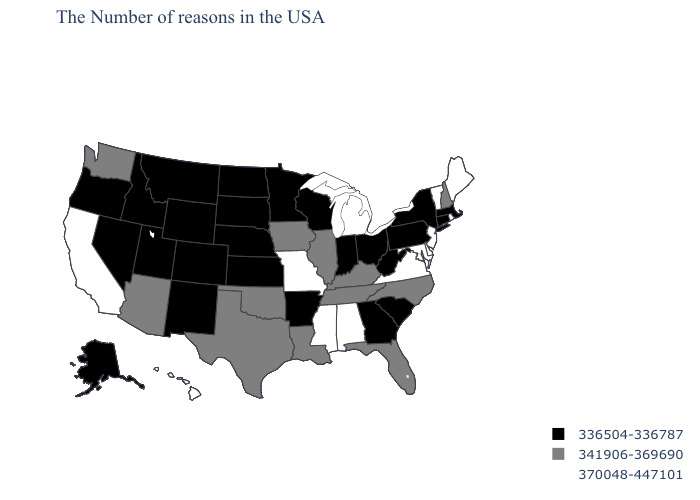What is the value of Maine?
Give a very brief answer. 370048-447101. Which states have the lowest value in the USA?
Be succinct. Massachusetts, Connecticut, New York, Pennsylvania, South Carolina, West Virginia, Ohio, Georgia, Indiana, Wisconsin, Arkansas, Minnesota, Kansas, Nebraska, South Dakota, North Dakota, Wyoming, Colorado, New Mexico, Utah, Montana, Idaho, Nevada, Oregon, Alaska. Name the states that have a value in the range 370048-447101?
Quick response, please. Maine, Rhode Island, Vermont, New Jersey, Delaware, Maryland, Virginia, Michigan, Alabama, Mississippi, Missouri, California, Hawaii. Which states have the lowest value in the South?
Write a very short answer. South Carolina, West Virginia, Georgia, Arkansas. What is the highest value in the West ?
Short answer required. 370048-447101. Name the states that have a value in the range 336504-336787?
Write a very short answer. Massachusetts, Connecticut, New York, Pennsylvania, South Carolina, West Virginia, Ohio, Georgia, Indiana, Wisconsin, Arkansas, Minnesota, Kansas, Nebraska, South Dakota, North Dakota, Wyoming, Colorado, New Mexico, Utah, Montana, Idaho, Nevada, Oregon, Alaska. Name the states that have a value in the range 341906-369690?
Short answer required. New Hampshire, North Carolina, Florida, Kentucky, Tennessee, Illinois, Louisiana, Iowa, Oklahoma, Texas, Arizona, Washington. What is the lowest value in the MidWest?
Write a very short answer. 336504-336787. Name the states that have a value in the range 336504-336787?
Be succinct. Massachusetts, Connecticut, New York, Pennsylvania, South Carolina, West Virginia, Ohio, Georgia, Indiana, Wisconsin, Arkansas, Minnesota, Kansas, Nebraska, South Dakota, North Dakota, Wyoming, Colorado, New Mexico, Utah, Montana, Idaho, Nevada, Oregon, Alaska. Which states have the highest value in the USA?
Be succinct. Maine, Rhode Island, Vermont, New Jersey, Delaware, Maryland, Virginia, Michigan, Alabama, Mississippi, Missouri, California, Hawaii. What is the value of Kentucky?
Give a very brief answer. 341906-369690. What is the value of Alaska?
Give a very brief answer. 336504-336787. Among the states that border Illinois , does Iowa have the lowest value?
Write a very short answer. No. Name the states that have a value in the range 336504-336787?
Concise answer only. Massachusetts, Connecticut, New York, Pennsylvania, South Carolina, West Virginia, Ohio, Georgia, Indiana, Wisconsin, Arkansas, Minnesota, Kansas, Nebraska, South Dakota, North Dakota, Wyoming, Colorado, New Mexico, Utah, Montana, Idaho, Nevada, Oregon, Alaska. What is the value of Utah?
Concise answer only. 336504-336787. 